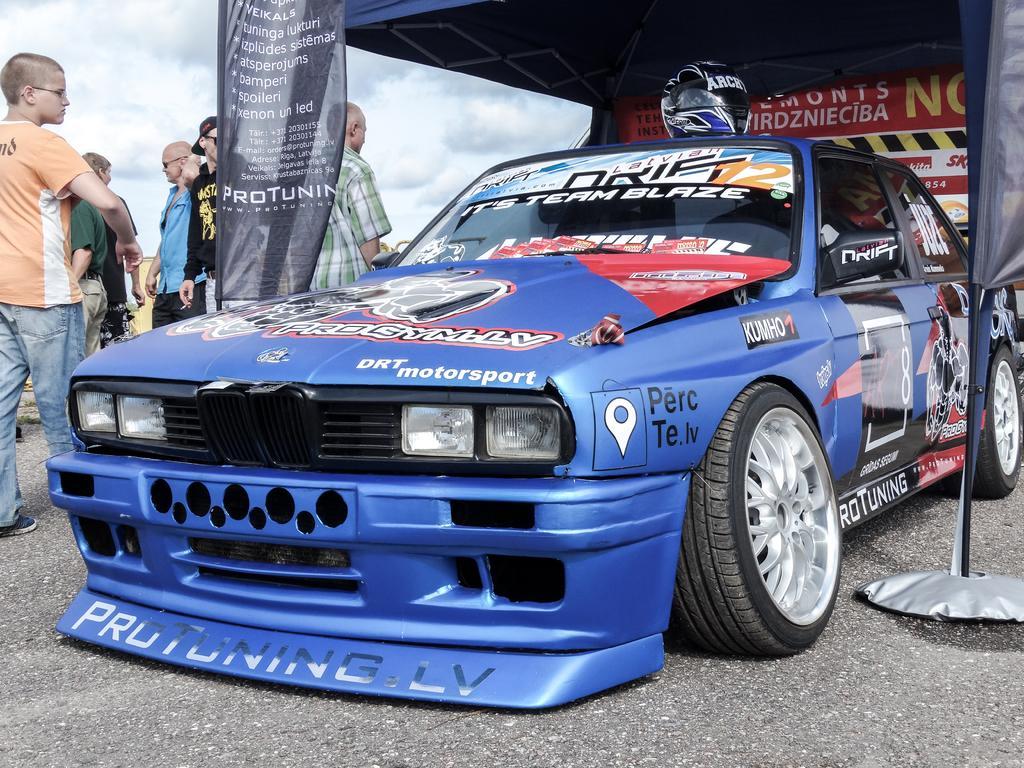Can you describe this image briefly? In this image there is a sports car which is kept below the tent. Above the car there is a helmet. On the left side there are few people standing on the floor beside the car. There are two banners on either side of the car. 